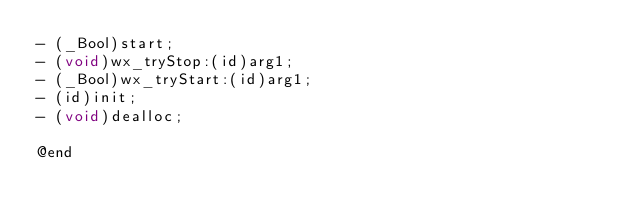<code> <loc_0><loc_0><loc_500><loc_500><_C_>- (_Bool)start;
- (void)wx_tryStop:(id)arg1;
- (_Bool)wx_tryStart:(id)arg1;
- (id)init;
- (void)dealloc;

@end

</code> 